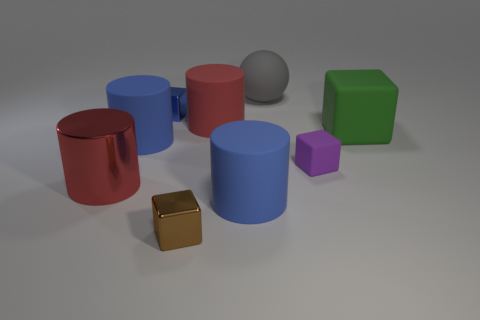Is there any other thing that is the same shape as the gray rubber object?
Your answer should be compact. No. There is a large red object that is to the left of the cylinder that is behind the green rubber thing; are there any metal cubes that are in front of it?
Give a very brief answer. Yes. What number of large green blocks have the same material as the small brown cube?
Your answer should be very brief. 0. There is a metallic object behind the green object; does it have the same size as the shiny thing on the right side of the small blue metallic cube?
Provide a succinct answer. Yes. There is a tiny cube that is behind the green thing in front of the large red cylinder to the right of the large metal cylinder; what is its color?
Make the answer very short. Blue. Are there any other large matte objects of the same shape as the green matte object?
Make the answer very short. No. Are there the same number of small objects that are to the left of the red matte object and big objects that are to the right of the large red metal cylinder?
Keep it short and to the point. No. There is a small object that is left of the small brown cube; does it have the same shape as the purple rubber object?
Offer a very short reply. Yes. Is the shape of the purple rubber thing the same as the gray object?
Your answer should be compact. No. How many matte things are big red cylinders or cylinders?
Give a very brief answer. 3. 